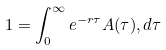Convert formula to latex. <formula><loc_0><loc_0><loc_500><loc_500>1 = \int _ { 0 } ^ { \infty } e ^ { - r \tau } A ( \tau ) , d \tau</formula> 